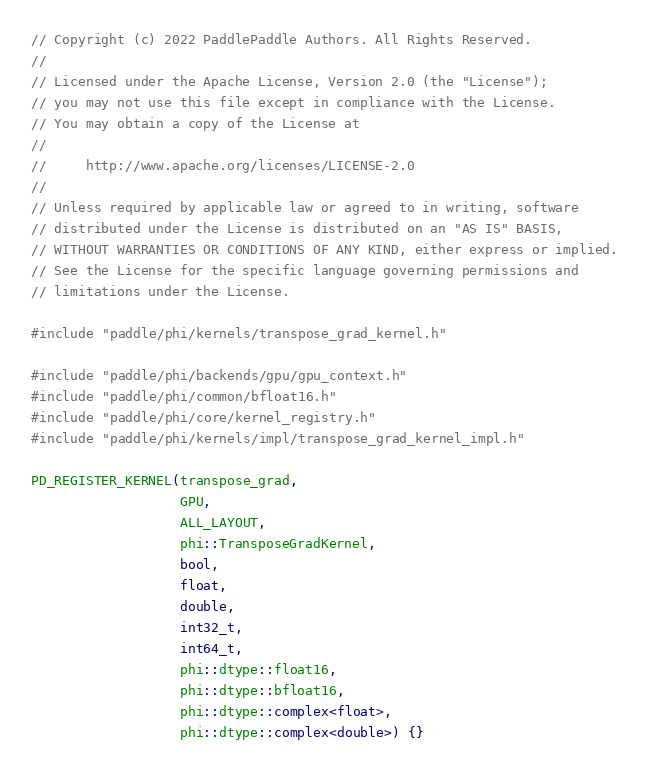Convert code to text. <code><loc_0><loc_0><loc_500><loc_500><_Cuda_>// Copyright (c) 2022 PaddlePaddle Authors. All Rights Reserved.
//
// Licensed under the Apache License, Version 2.0 (the "License");
// you may not use this file except in compliance with the License.
// You may obtain a copy of the License at
//
//     http://www.apache.org/licenses/LICENSE-2.0
//
// Unless required by applicable law or agreed to in writing, software
// distributed under the License is distributed on an "AS IS" BASIS,
// WITHOUT WARRANTIES OR CONDITIONS OF ANY KIND, either express or implied.
// See the License for the specific language governing permissions and
// limitations under the License.

#include "paddle/phi/kernels/transpose_grad_kernel.h"

#include "paddle/phi/backends/gpu/gpu_context.h"
#include "paddle/phi/common/bfloat16.h"
#include "paddle/phi/core/kernel_registry.h"
#include "paddle/phi/kernels/impl/transpose_grad_kernel_impl.h"

PD_REGISTER_KERNEL(transpose_grad,
                   GPU,
                   ALL_LAYOUT,
                   phi::TransposeGradKernel,
                   bool,
                   float,
                   double,
                   int32_t,
                   int64_t,
                   phi::dtype::float16,
                   phi::dtype::bfloat16,
                   phi::dtype::complex<float>,
                   phi::dtype::complex<double>) {}
</code> 